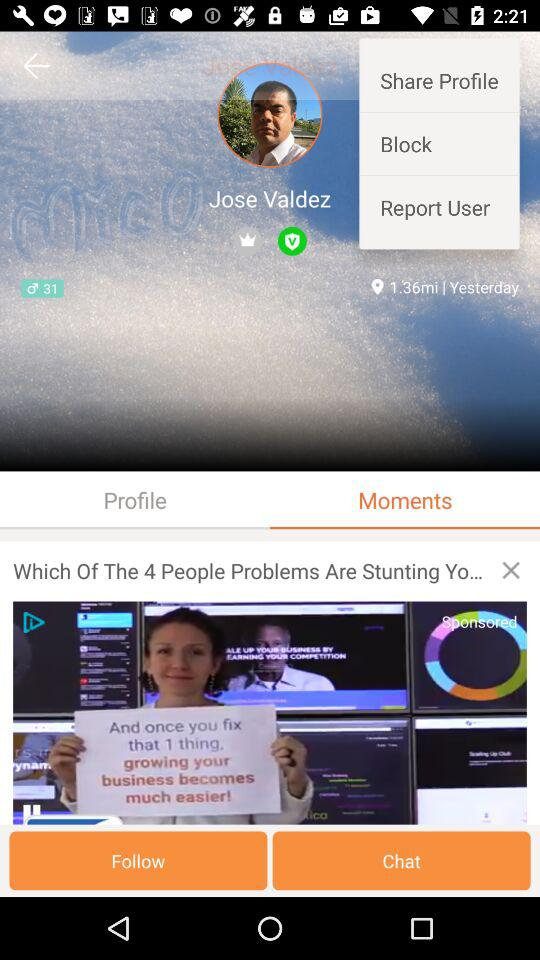Which tab has been selected? The selected tab is "Moments". 